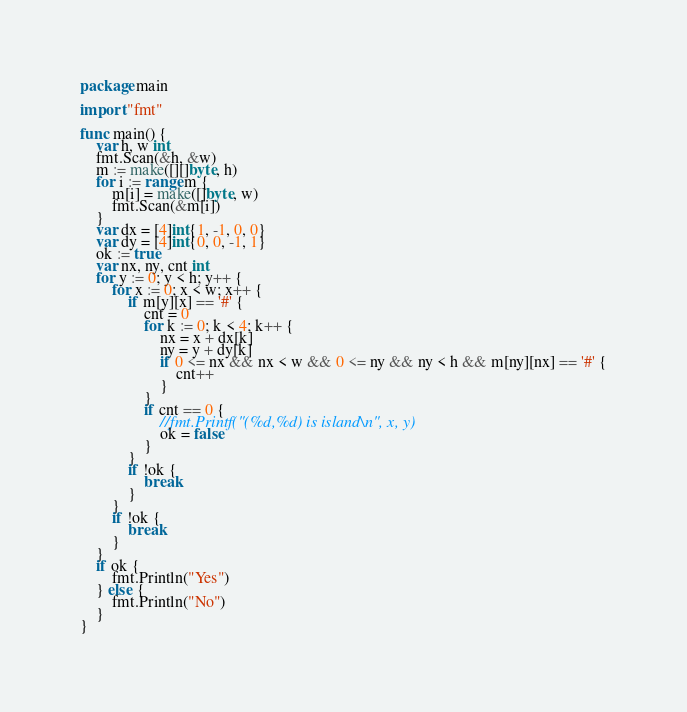<code> <loc_0><loc_0><loc_500><loc_500><_Go_>package main

import "fmt"

func main() {
	var h, w int
	fmt.Scan(&h, &w)
	m := make([][]byte, h)
	for i := range m {
		m[i] = make([]byte, w)
		fmt.Scan(&m[i])
	}
	var dx = [4]int{1, -1, 0, 0}
	var dy = [4]int{0, 0, -1, 1}
	ok := true
	var nx, ny, cnt int
	for y := 0; y < h; y++ {
		for x := 0; x < w; x++ {
			if m[y][x] == '#' {
				cnt = 0
				for k := 0; k < 4; k++ {
					nx = x + dx[k]
					ny = y + dy[k]
					if 0 <= nx && nx < w && 0 <= ny && ny < h && m[ny][nx] == '#' {
						cnt++
					}
				}
				if cnt == 0 {
					//fmt.Printf("(%d,%d) is island\n", x, y)
					ok = false
				}
			}
			if !ok {
				break
			}
		}
		if !ok {
			break
		}
	}
	if ok {
		fmt.Println("Yes")
	} else {
		fmt.Println("No")
	}
}
</code> 